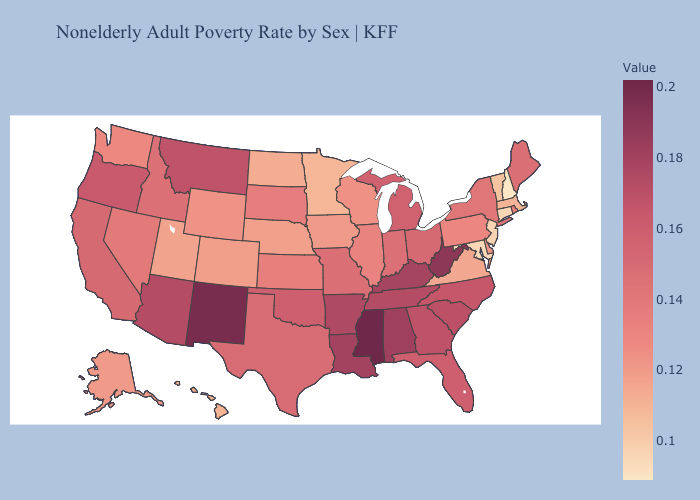Does Nebraska have the highest value in the MidWest?
Short answer required. No. Does Mississippi have the highest value in the USA?
Short answer required. Yes. Does Idaho have the lowest value in the West?
Concise answer only. No. 